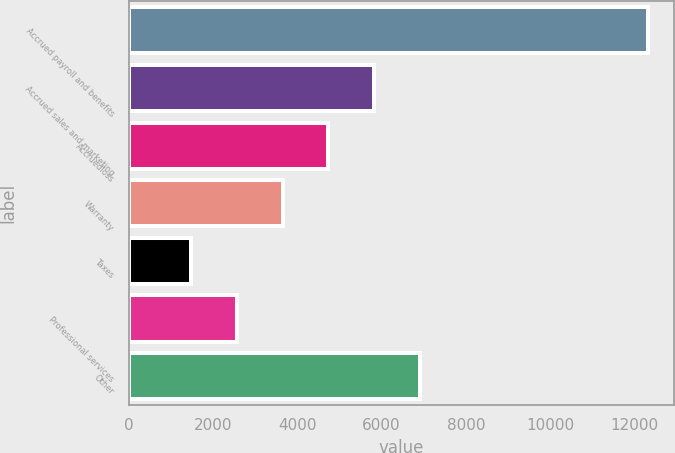Convert chart. <chart><loc_0><loc_0><loc_500><loc_500><bar_chart><fcel>Accrued payroll and benefits<fcel>Accrued sales and marketing<fcel>Accruedloss<fcel>Warranty<fcel>Taxes<fcel>Professional services<fcel>Other<nl><fcel>12330<fcel>5821.8<fcel>4737.1<fcel>3652.4<fcel>1483<fcel>2567.7<fcel>6906.5<nl></chart> 